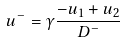Convert formula to latex. <formula><loc_0><loc_0><loc_500><loc_500>u ^ { - } = \gamma \frac { - u _ { 1 } + u _ { 2 } } { D ^ { - } }</formula> 